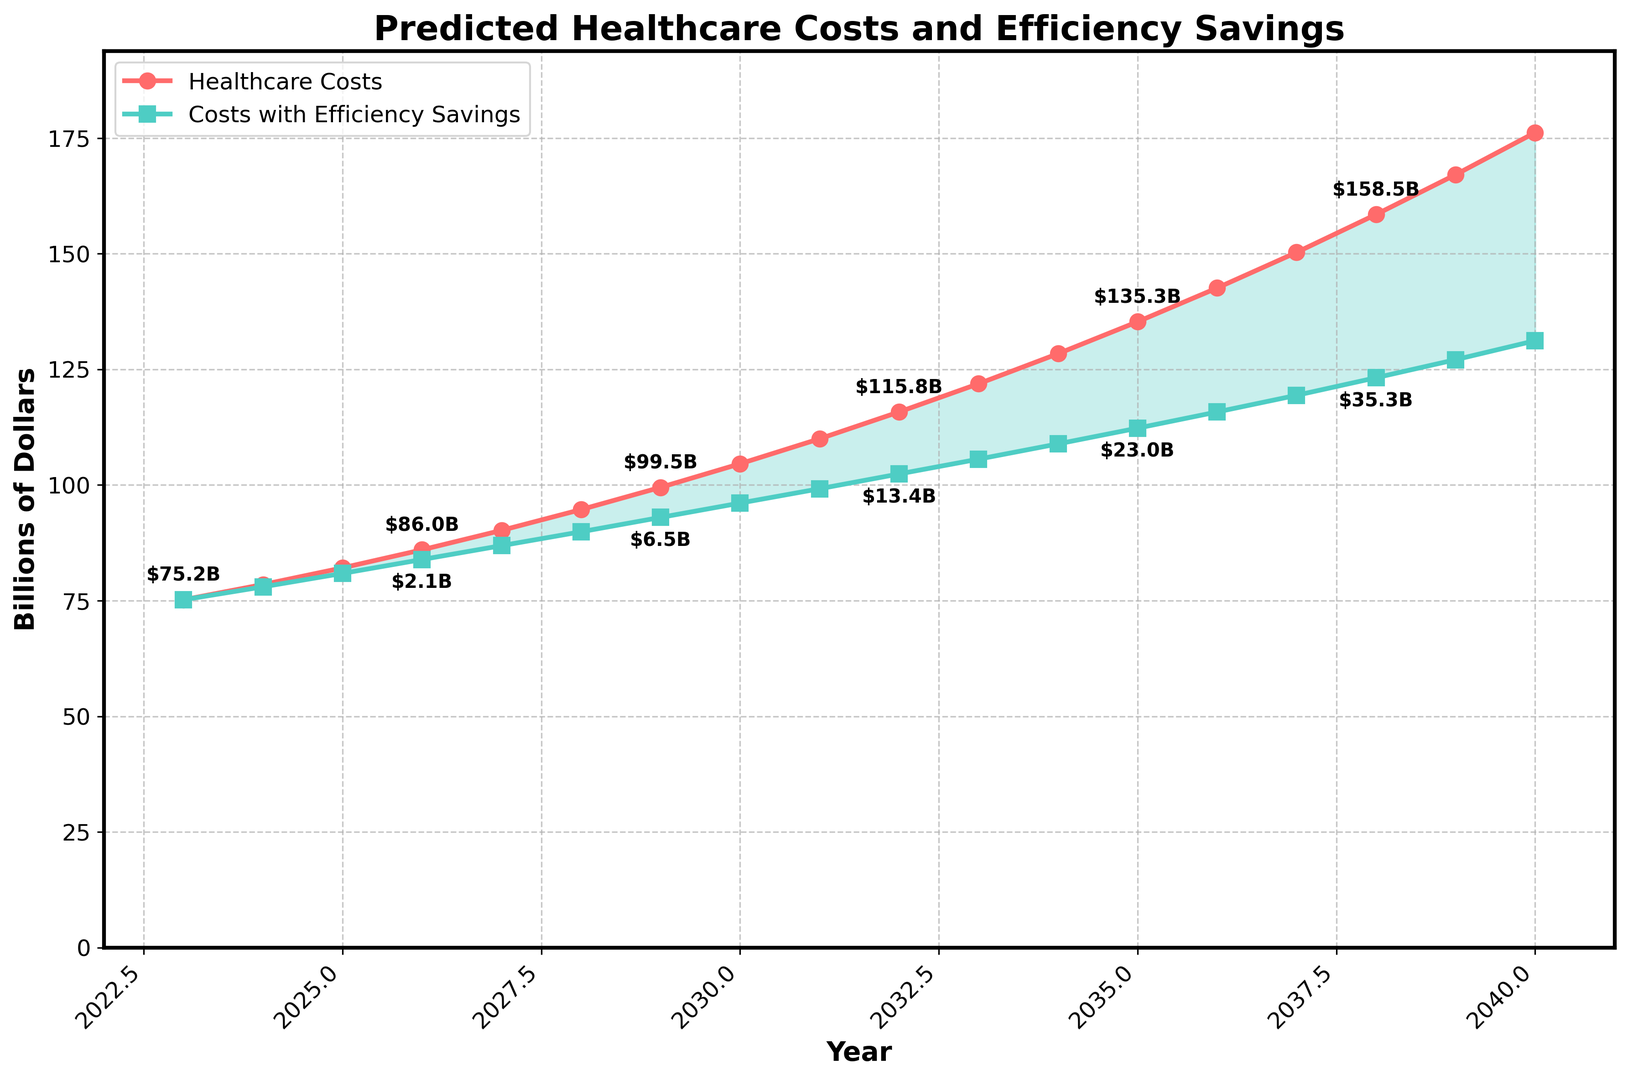What is the projected healthcare cost in 2030? According to the figure, the projected healthcare cost in 2030 is marked with a red point labeled as `$104.6B`. Simply find the year 2030 on the x-axis and locate the corresponding point for healthcare costs.
Answer: $104.6B How much are the efficiency savings expected to be in 2035? Find the year 2035 on the x-axis and look for the annotated value for efficiency savings. In 2035, it is labeled as `$23.0B`.
Answer: $23.0B What is the difference between projected healthcare costs and the costs with efficiency savings in 2040? In 2040, the projected healthcare cost is `$176.2B` and the efficiency savings are `$45.0B`. To find the difference, subtract the efficiency savings from the projected cost: $176.2B - $45.0B = $131.2B.
Answer: $131.2B Which year shows the largest efficiency savings on the chart, and what is the amount? Scan through the values for efficiency savings to find the largest one. The largest efficiency savings are in 2040, marked as `$45.0B`.
Answer: 2040, $45.0B How do the healthcare costs and efficiency savings grow from 2023 to 2040? Observe the trend lines: Healthcare costs rise from `$75.2B` in 2023 to `$176.2B` in 2040. The efficiency savings start from `$0.0B` in 2023 and increase to `$45.0B` in 2040. This indicates a steady growth in both costs and savings over these years.
Answer: Steady growth in both costs and savings What is the cumulative efficiency savings by 2035? Add the values of efficiency savings from 2023 to 2035: $0.0B + $0.5B + $1.2B + $2.1B + $3.3B + $4.8B + $6.5B + $8.5B + $10.8B + $13.4B + $16.3B + $19.5B + $23.0B = $110.4B.
Answer: $110.4B How much more is the healthcare cost in 2038 compared to 2033? Find the healthcare costs for 2038 and 2033, which are `$158.5B` and `$121.9B` respectively. Subtract the 2033 cost from the 2038 cost: $158.5B - $121.9B = $36.6B.
Answer: $36.6B Which year between 2023 and 2040 first sees efficiency savings surpass $10B? Look for when efficiency savings first exceed $10B. It happens in 2031 with savings labeled as `$10.8B`.
Answer: 2031 What is the trend in the amount filled between the projected costs and costs with efficiency savings? The area between the healthcare costs and costs with efficiency savings increases over time, indicating growing efficiency measures reducing the net costs.
Answer: Increasing gap over time At what year does the net healthcare cost (projected cost - efficiency savings) break the $100B mark? Find when net healthcare cost first exceeds $100B. It occurs in 2035: $135.3B (cost) - $23.0B (savings) = $112.3B.
Answer: 2035 